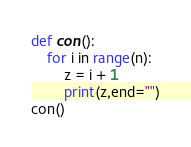Convert code to text. <code><loc_0><loc_0><loc_500><loc_500><_Python_>def con():
    for i in range(n):
        z = i + 1
        print(z,end="")
con()</code> 